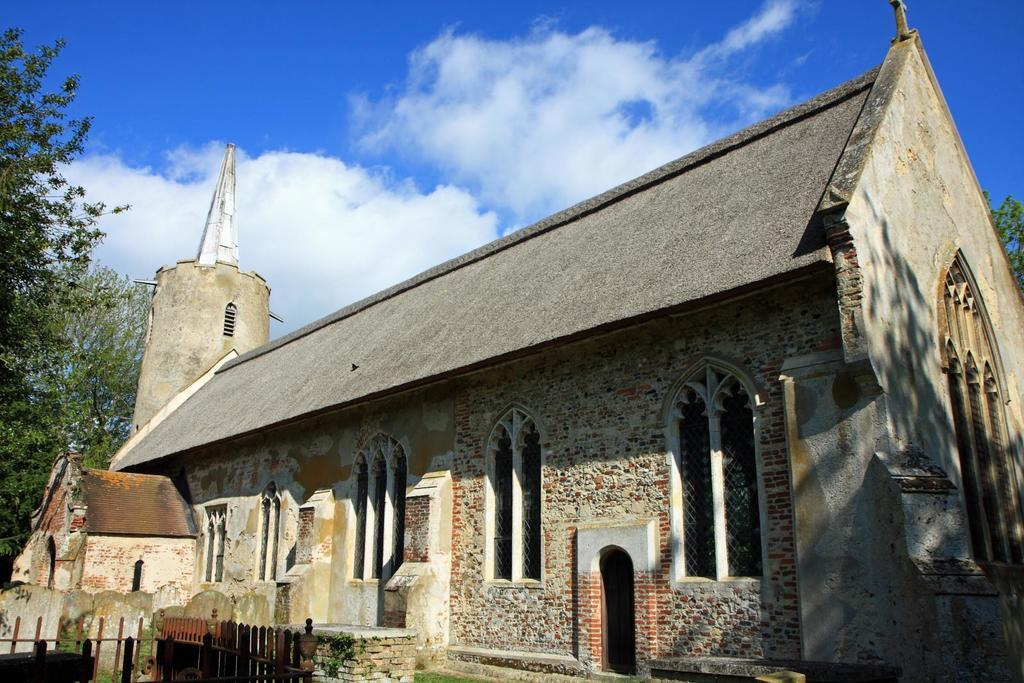What type of structure is in the image? There is a house in the image. What material is used for the walls of the house? The house has brick walls. What features can be seen on the house? The house has windows and grills. What is visible at the bottom of the image? There is grass, fencing, and plants at the bottom of the image. What can be seen in the background of the image? There are trees and a cloudy sky in the background of the image. What type of harmony is being played by the musicians in the image? There are no musicians or any indication of music in the image. What badge is the person wearing on their uniform in the image? There is no person or uniform present in the image. 